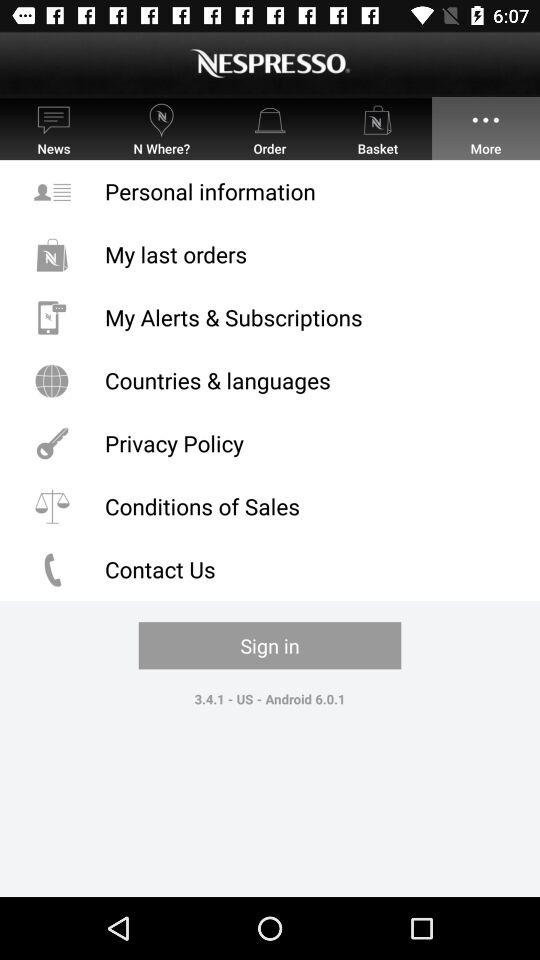Which tab is selected? The selected tab is "More". 